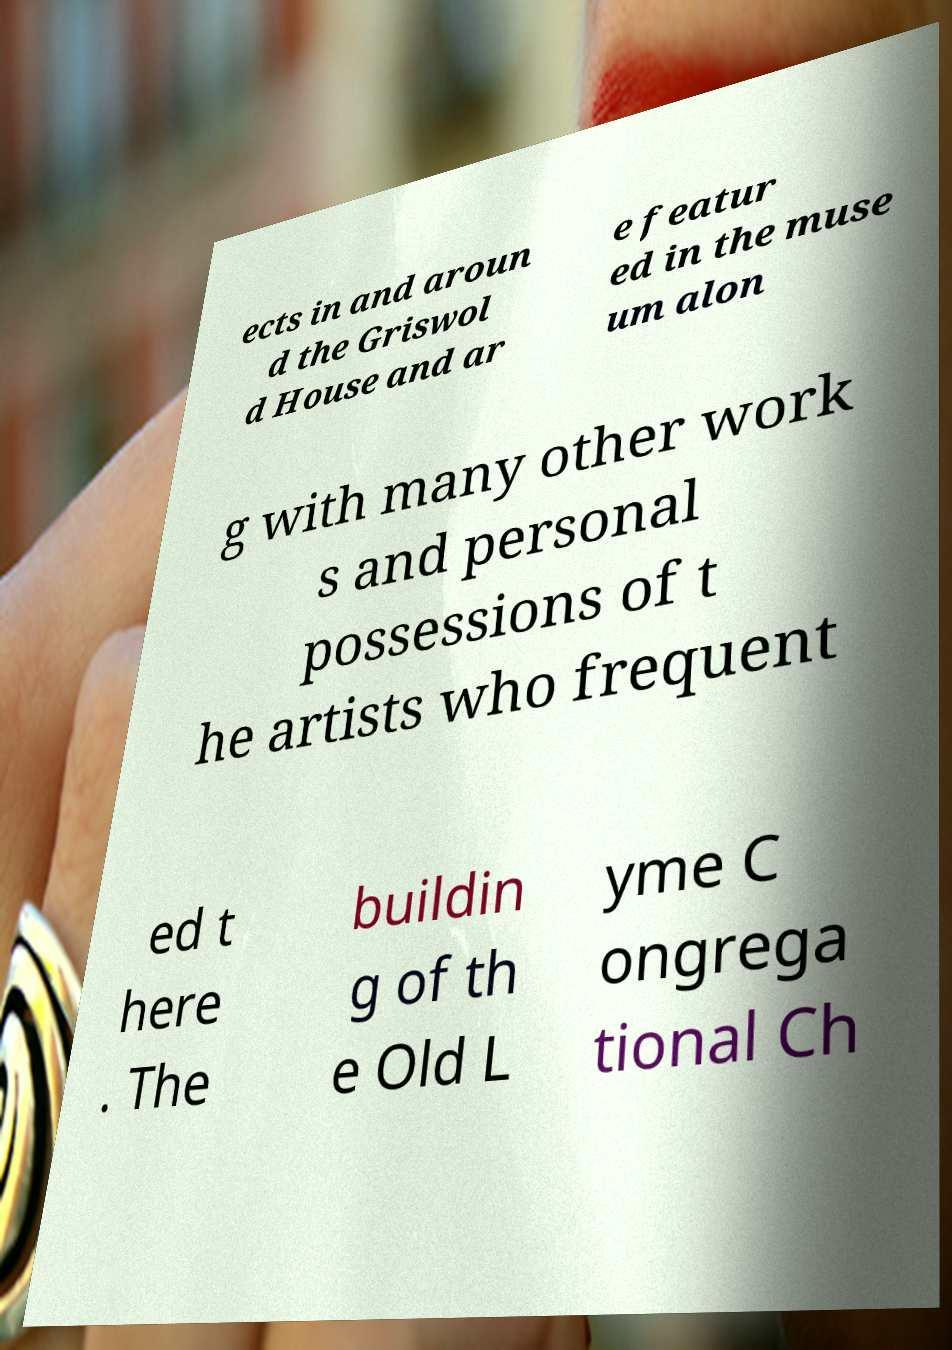Could you extract and type out the text from this image? ects in and aroun d the Griswol d House and ar e featur ed in the muse um alon g with many other work s and personal possessions of t he artists who frequent ed t here . The buildin g of th e Old L yme C ongrega tional Ch 